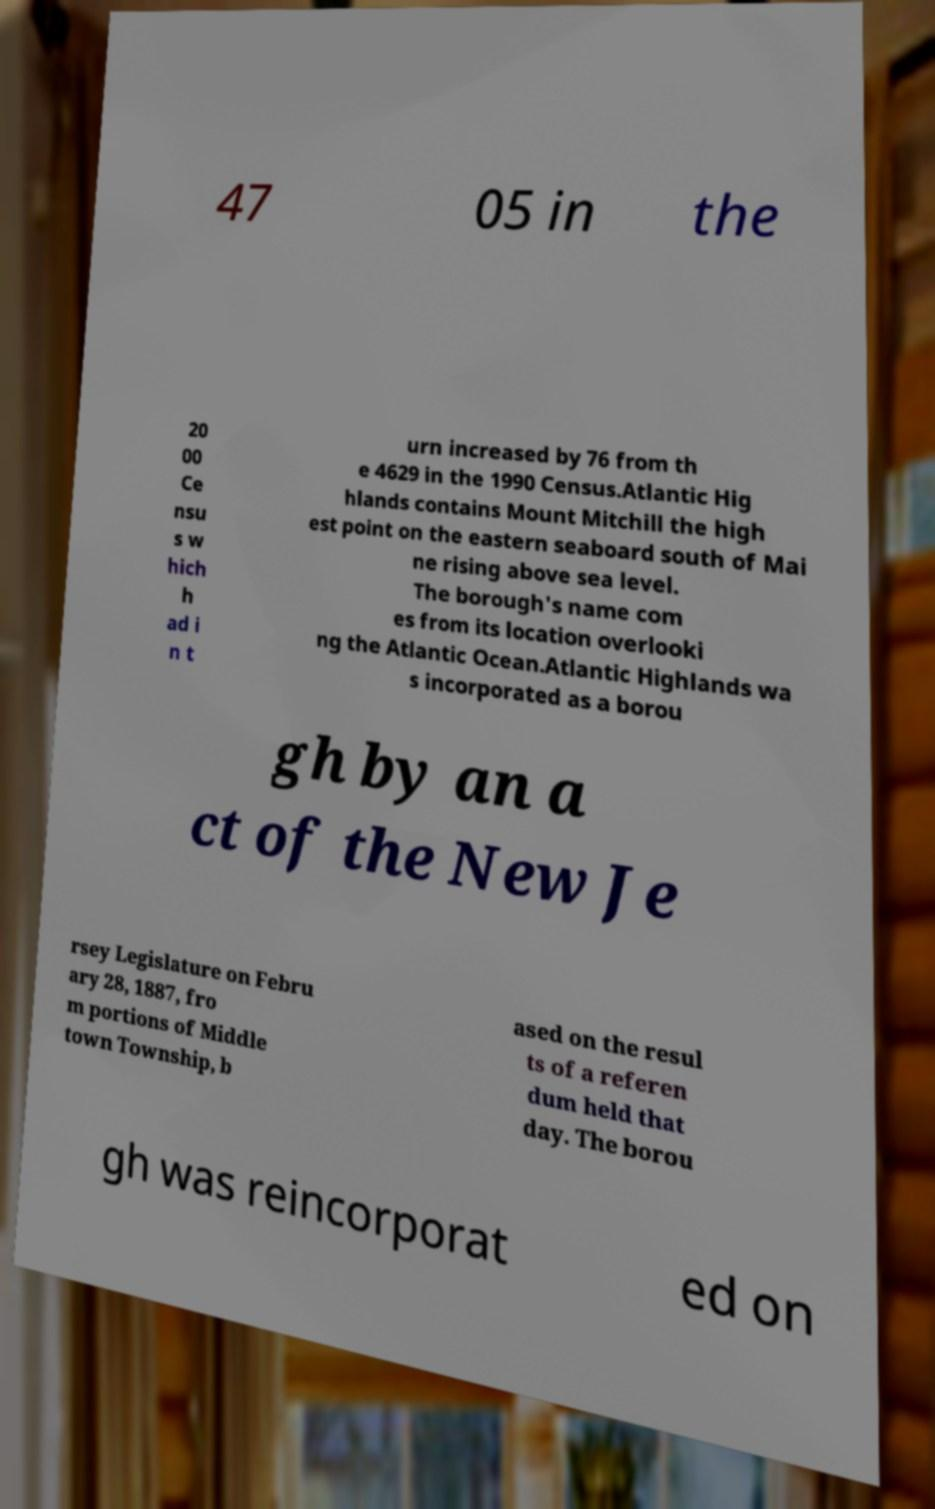Could you extract and type out the text from this image? 47 05 in the 20 00 Ce nsu s w hich h ad i n t urn increased by 76 from th e 4629 in the 1990 Census.Atlantic Hig hlands contains Mount Mitchill the high est point on the eastern seaboard south of Mai ne rising above sea level. The borough's name com es from its location overlooki ng the Atlantic Ocean.Atlantic Highlands wa s incorporated as a borou gh by an a ct of the New Je rsey Legislature on Febru ary 28, 1887, fro m portions of Middle town Township, b ased on the resul ts of a referen dum held that day. The borou gh was reincorporat ed on 